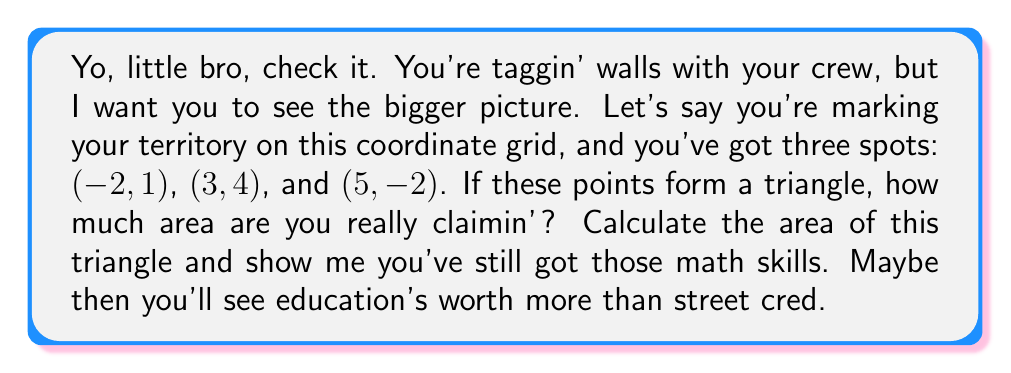Provide a solution to this math problem. Alright, let's break this down step-by-step:

1) To find the area of a triangle given three points on a coordinate plane, we can use the formula:

   $$\text{Area} = \frac{1}{2}|x_1(y_2 - y_3) + x_2(y_3 - y_1) + x_3(y_1 - y_2)|$$

   Where $(x_1, y_1)$, $(x_2, y_2)$, and $(x_3, y_3)$ are the coordinates of the three points.

2) Let's assign our points:
   $(x_1, y_1) = (-2, 1)$
   $(x_2, y_2) = (3, 4)$
   $(x_3, y_3) = (5, -2)$

3) Now, let's plug these into our formula:

   $$\text{Area} = \frac{1}{2}|(-2)(4 - (-2)) + (3)((-2) - 1) + (5)(1 - 4)|$$

4) Let's simplify inside the parentheses:

   $$\text{Area} = \frac{1}{2}|(-2)(6) + (3)(-3) + (5)(-3)|$$

5) Multiply:

   $$\text{Area} = \frac{1}{2}|-12 - 9 - 15|$$

6) Add inside the absolute value signs:

   $$\text{Area} = \frac{1}{2}|-36|$$

7) The absolute value of -36 is 36:

   $$\text{Area} = \frac{1}{2}(36)$$

8) Finally, divide:

   $$\text{Area} = 18$$

So, the area of the triangle is 18 square units.

[asy]
unitsize(20);
draw((-3,-3)--(6,5),arrow=Arrow(TeXHead));
draw((-3,-3)--(-3,5),arrow=Arrow(TeXHead));
for (int i=-2; i<=5; ++i) {
  draw((i,-0.1)--(i,0.1));
  label(string(i),(i,-0.5),S);
}
for (int i=-2; i<=4; ++i) {
  draw((-0.1,i)--(0.1,i));
  label(string(i),(-0.5,i),W);
}
dot((-2,1));
dot((3,4));
dot((5,-2));
draw((-2,1)--(3,4)--(5,-2)--cycle,blue);
label("(-2,1)",(-2,1),NW);
label("(3,4)",(3,4),NE);
label("(5,-2)",(5,-2),SE);
[/asy]
Answer: The area of the triangle is 18 square units. 